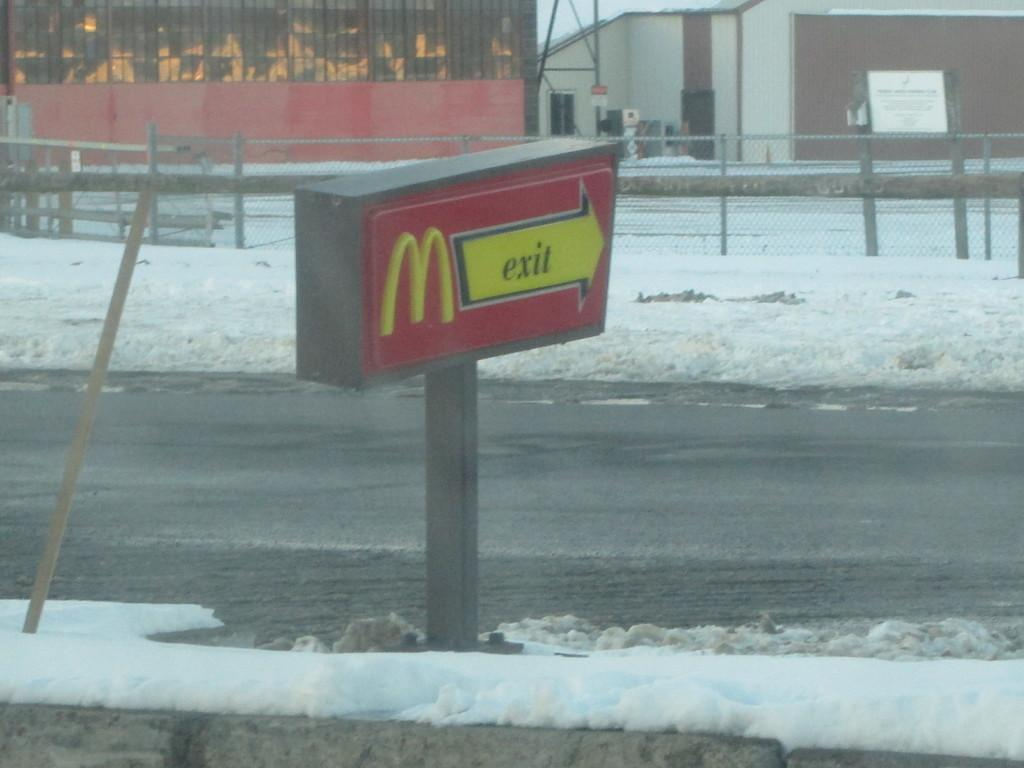Provide a one-sentence caption for the provided image. The sign from the drive through says exit. 